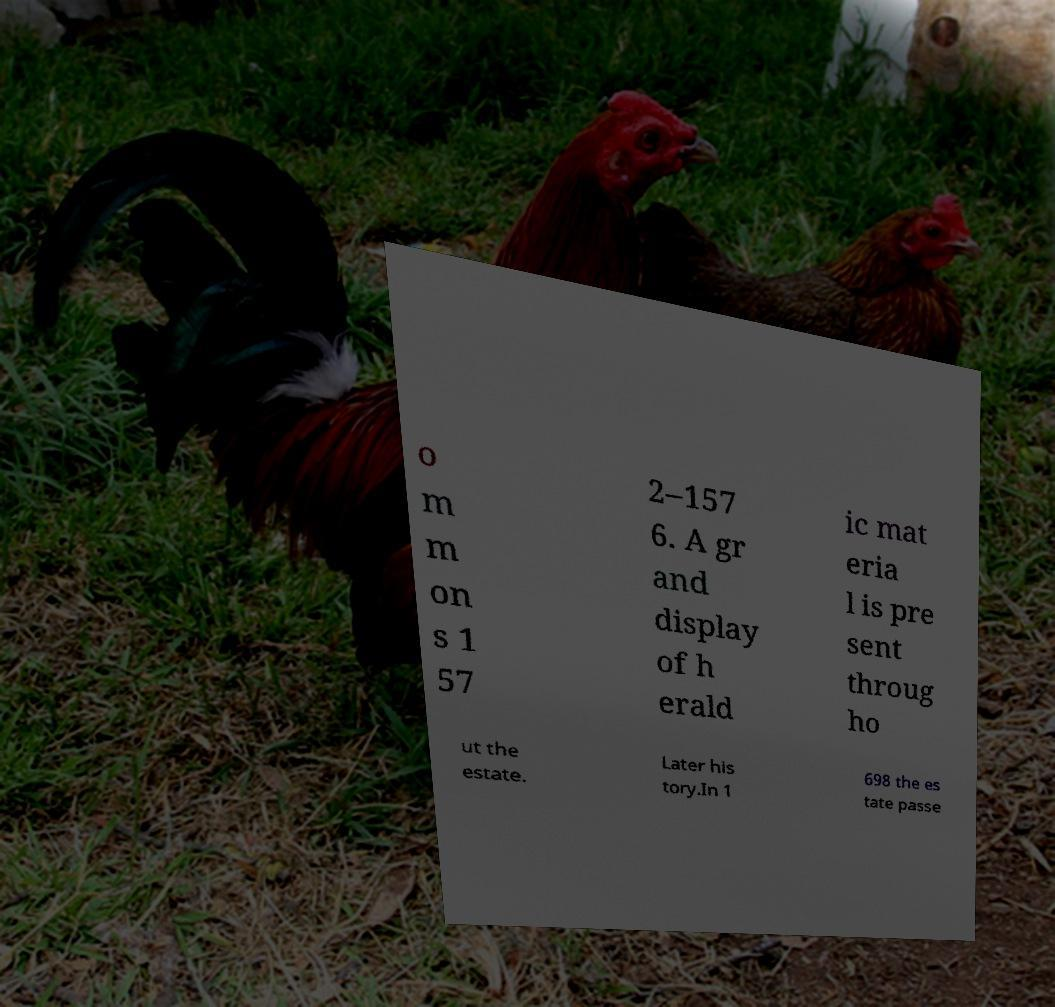Can you read and provide the text displayed in the image?This photo seems to have some interesting text. Can you extract and type it out for me? o m m on s 1 57 2–157 6. A gr and display of h erald ic mat eria l is pre sent throug ho ut the estate. Later his tory.In 1 698 the es tate passe 